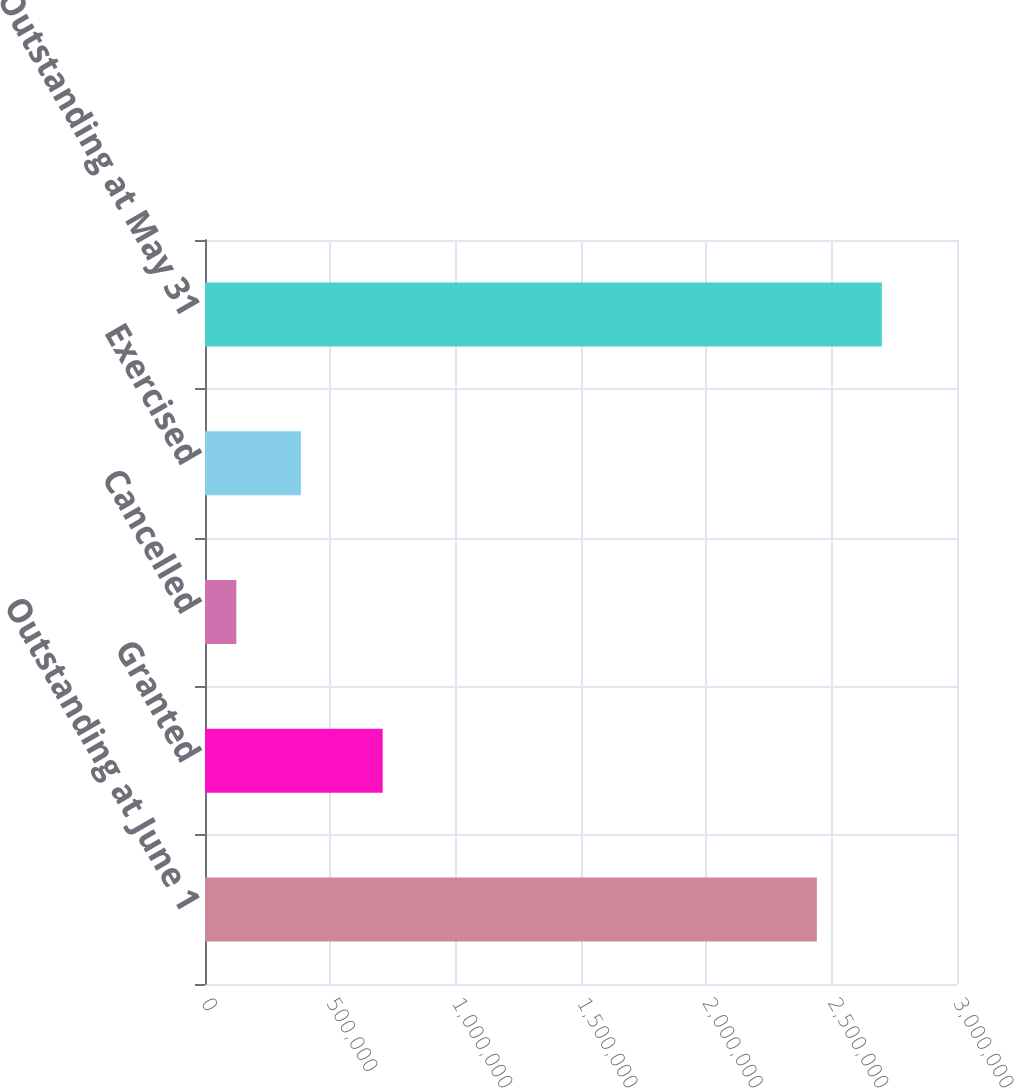Convert chart. <chart><loc_0><loc_0><loc_500><loc_500><bar_chart><fcel>Outstanding at June 1<fcel>Granted<fcel>Cancelled<fcel>Exercised<fcel>Outstanding at May 31<nl><fcel>2.441e+06<fcel>708768<fcel>124999<fcel>382533<fcel>2.70034e+06<nl></chart> 